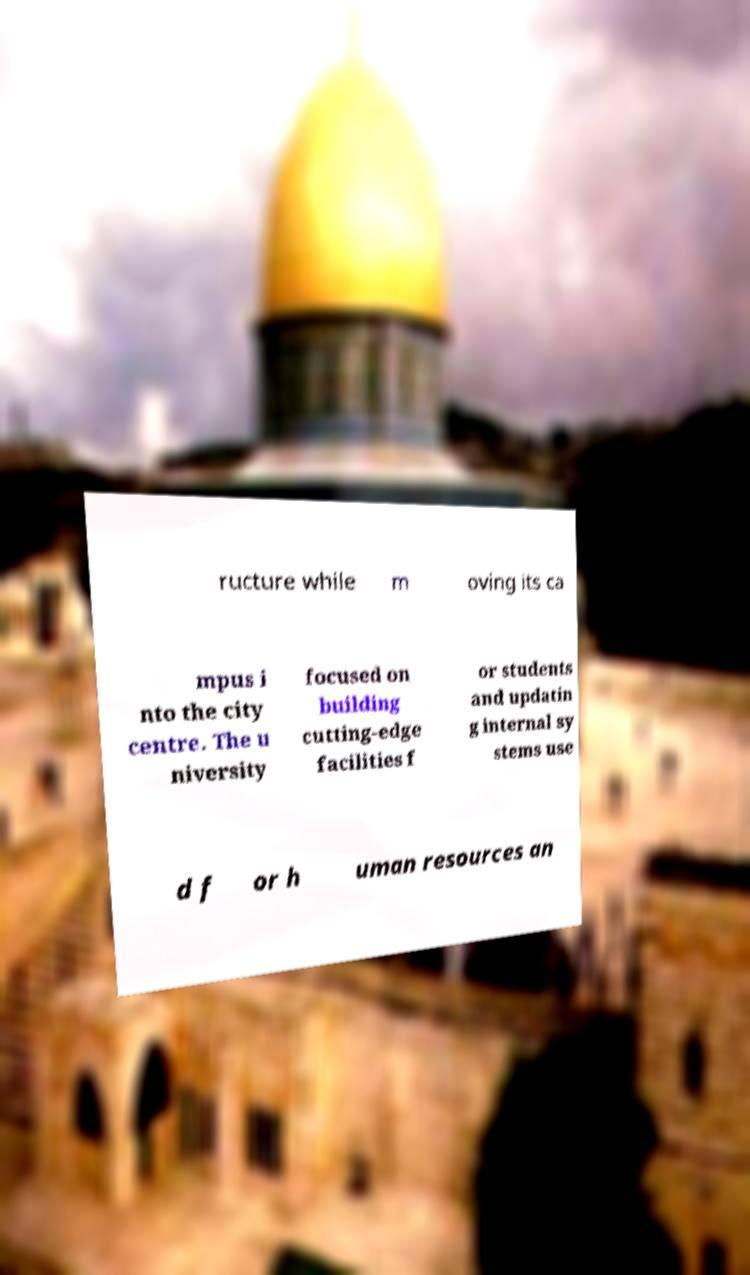There's text embedded in this image that I need extracted. Can you transcribe it verbatim? ructure while m oving its ca mpus i nto the city centre. The u niversity focused on building cutting-edge facilities f or students and updatin g internal sy stems use d f or h uman resources an 